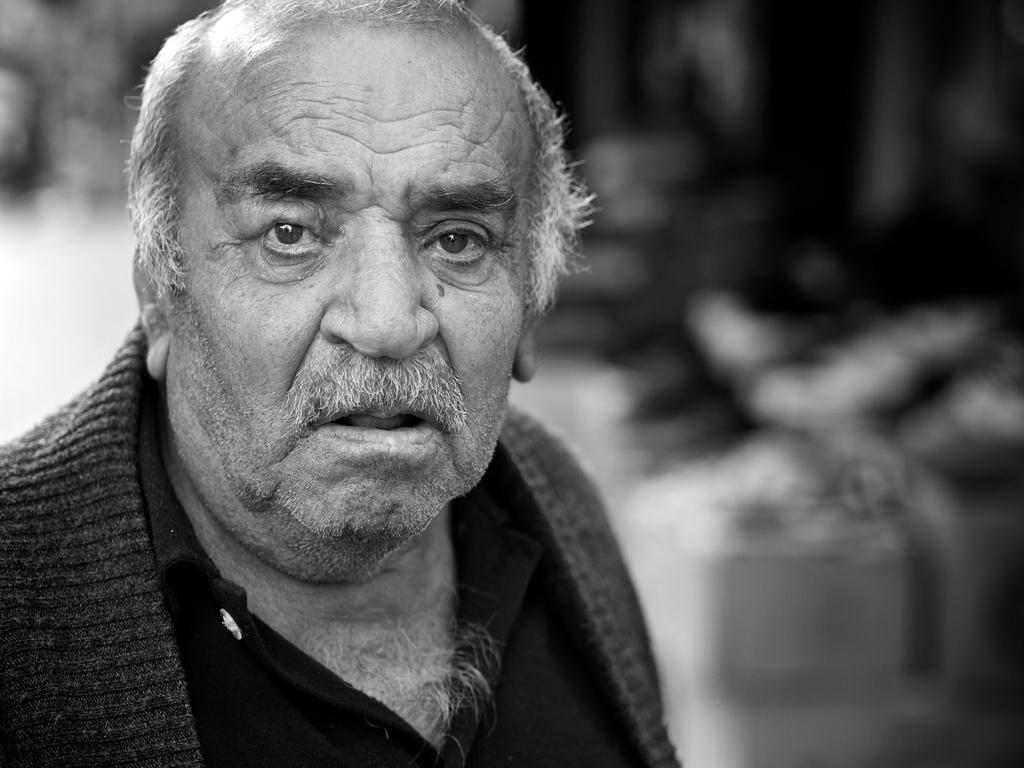What is the color scheme of the image? The image is black and white. Who or what is located in the foreground of the image? There is an old man in the foreground of the image. Can you describe the background of the image? The background of the image is blurred. How many cows can be seen grazing in the background of the image? There are no cows present in the image. What type of church can be seen in the background of the image? There is no church present in the image. What level of the building is the old man standing on in the image? The image does not provide information about the level of the building the old man is standing on. 